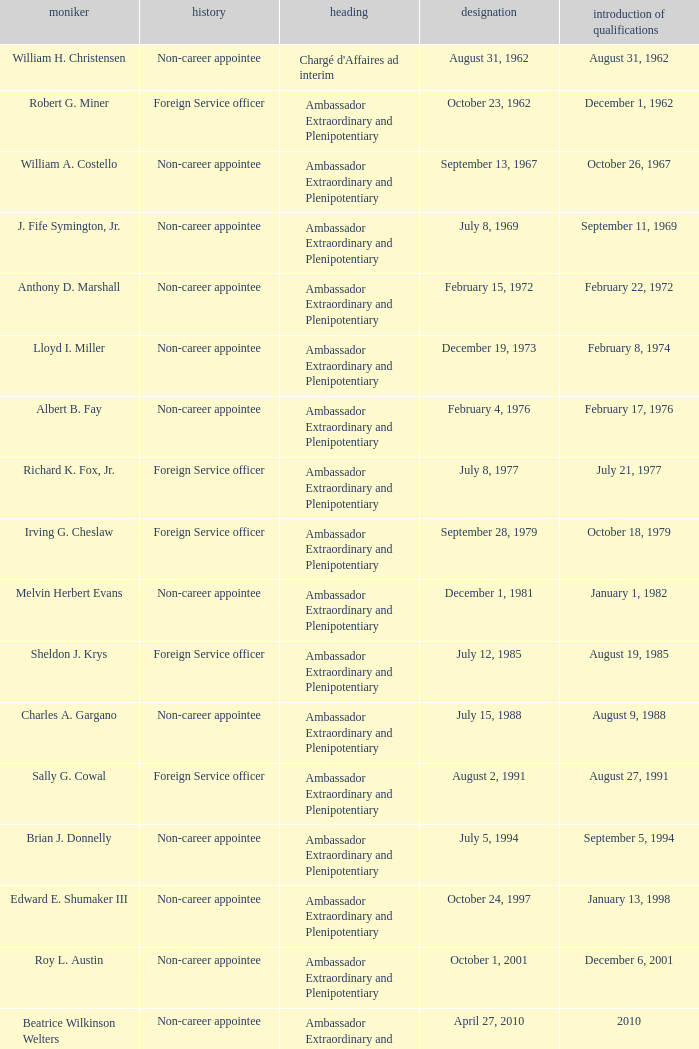Who was appointed on October 24, 1997? Edward E. Shumaker III. 